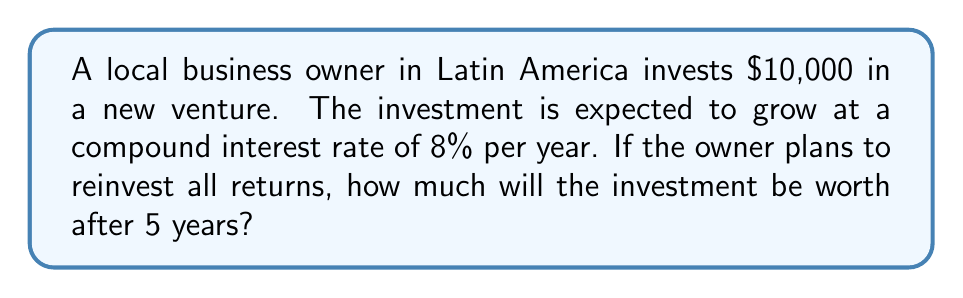What is the answer to this math problem? To solve this problem, we'll use the compound interest formula:

$$A = P(1 + r)^t$$

Where:
$A$ = Final amount
$P$ = Principal (initial investment)
$r$ = Annual interest rate (as a decimal)
$t$ = Time in years

Given:
$P = \$10,000$
$r = 0.08$ (8% expressed as a decimal)
$t = 5$ years

Let's substitute these values into the formula:

$$A = 10000(1 + 0.08)^5$$

Now, let's solve step-by-step:

1) First, calculate $(1 + 0.08)^5$:
   $$(1.08)^5 = 1.469328$$

2) Multiply this result by the principal:
   $$A = 10000 \times 1.469328 = 14693.28$$

Therefore, after 5 years, the investment will be worth $14,693.28.
Answer: $14,693.28 